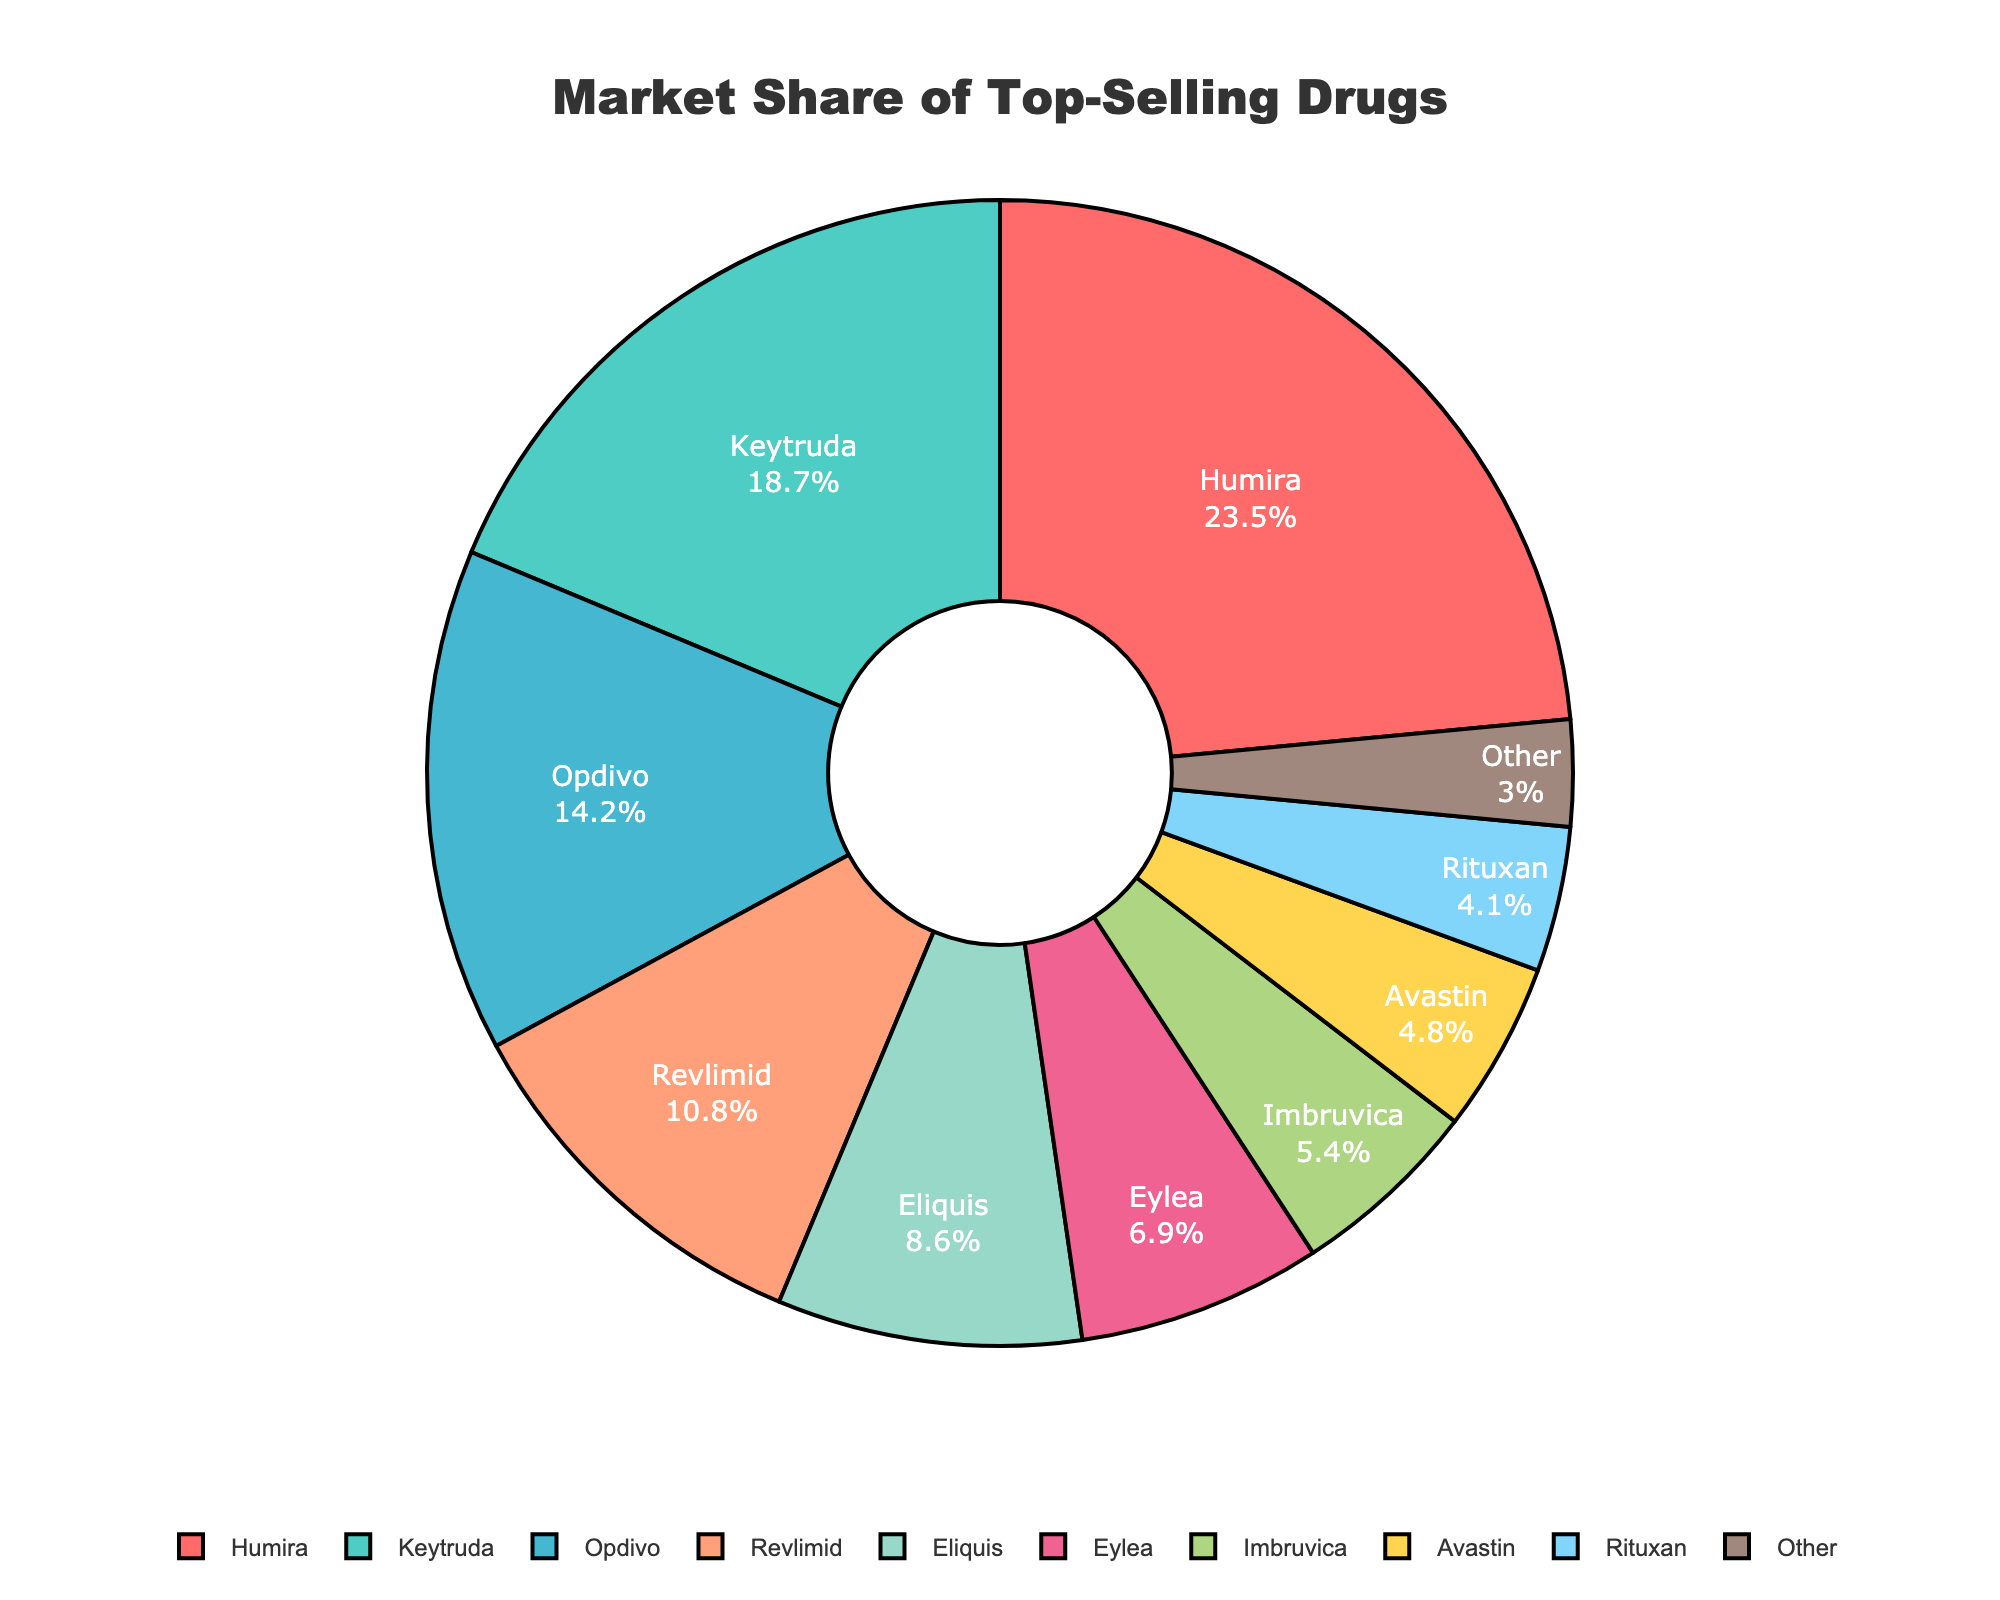What is the combined market share of Humira, Keytruda, and Opdivo? To find the combined market share of Humira, Keytruda, and Opdivo, add their individual market shares: 23.5 (Humira) + 18.7 (Keytruda) + 14.2 (Opdivo) = 56.4.
Answer: 56.4 Which drug has the highest market share and what is the value? By looking at the pie chart, Humira has the highest market share. The value is shown next to it as 23.5%.
Answer: Humira, 23.5% How does the market share of Opdivo compare to that of Eliquis? Opdivo has a market share of 14.2%, while Eliquis has a market share of 8.6%. By comparison, Opdivo's market share is higher than Eliquis's.
Answer: Opdivo's market share is higher than Eliquis's What is the color associated with Rituxan in the pie chart? Observing the pie chart, Rituxan is represented in the color light blue.
Answer: Light blue Which drugs have a market share less than 5%, and what are their combined market shares? The drugs with a market share less than 5% are Imbruvica (5.4%), Avastin (4.8%), Rituxan (4.1%), and Other (3.0%). Add their market shares to get the combined value: 5.4 + 4.8 + 4.1 + 3.0 = 17.3.
Answer: Imbruvica, Avastin, Rituxan, Other, 17.3 What percentage of the market share do the top three drugs account for? The top three drugs by market share are Humira (23.5%), Keytruda (18.7%), and Opdivo (14.2%). Their combined market share is: 23.5 + 18.7 + 14.2 = 56.4%.
Answer: 56.4% How does the market share of Eylea compare to the combined market share of Other and Rituxan? Eylea has a market share of 6.9%, while Other and Rituxan combined have 3.0% + 4.1% = 7.1%. Therefore, the combined market share of Other and Rituxan is slightly higher than that of Eylea.
Answer: Other and Rituxan's combined share is higher than Eylea's How many drugs have a market share greater than 10%? Drugs with market shares greater than 10% are Humira, Keytruda, Opdivo, and Revlimid. Count these drugs to find the total number: 4.
Answer: 4 What is the market share difference between the top-selling drug and the least-selling drug? The top-selling drug, Humira, has a market share of 23.5%, while the least-selling drug category labeled as Other has a market share of 3.0%. The difference is: 23.5 - 3.0 = 20.5%.
Answer: 20.5% 